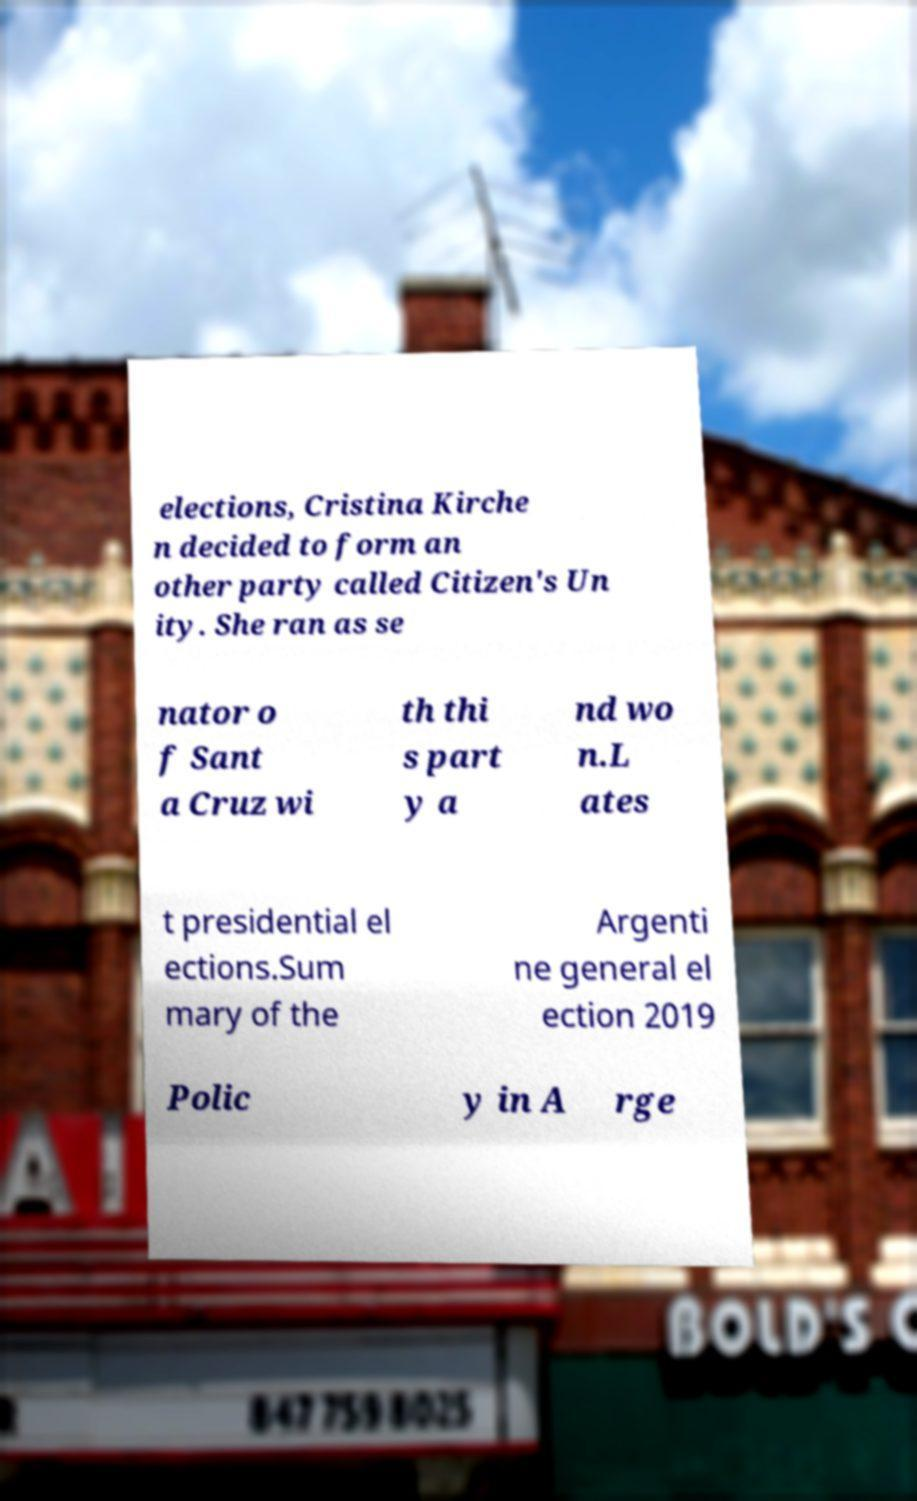Please identify and transcribe the text found in this image. elections, Cristina Kirche n decided to form an other party called Citizen's Un ity. She ran as se nator o f Sant a Cruz wi th thi s part y a nd wo n.L ates t presidential el ections.Sum mary of the Argenti ne general el ection 2019 Polic y in A rge 